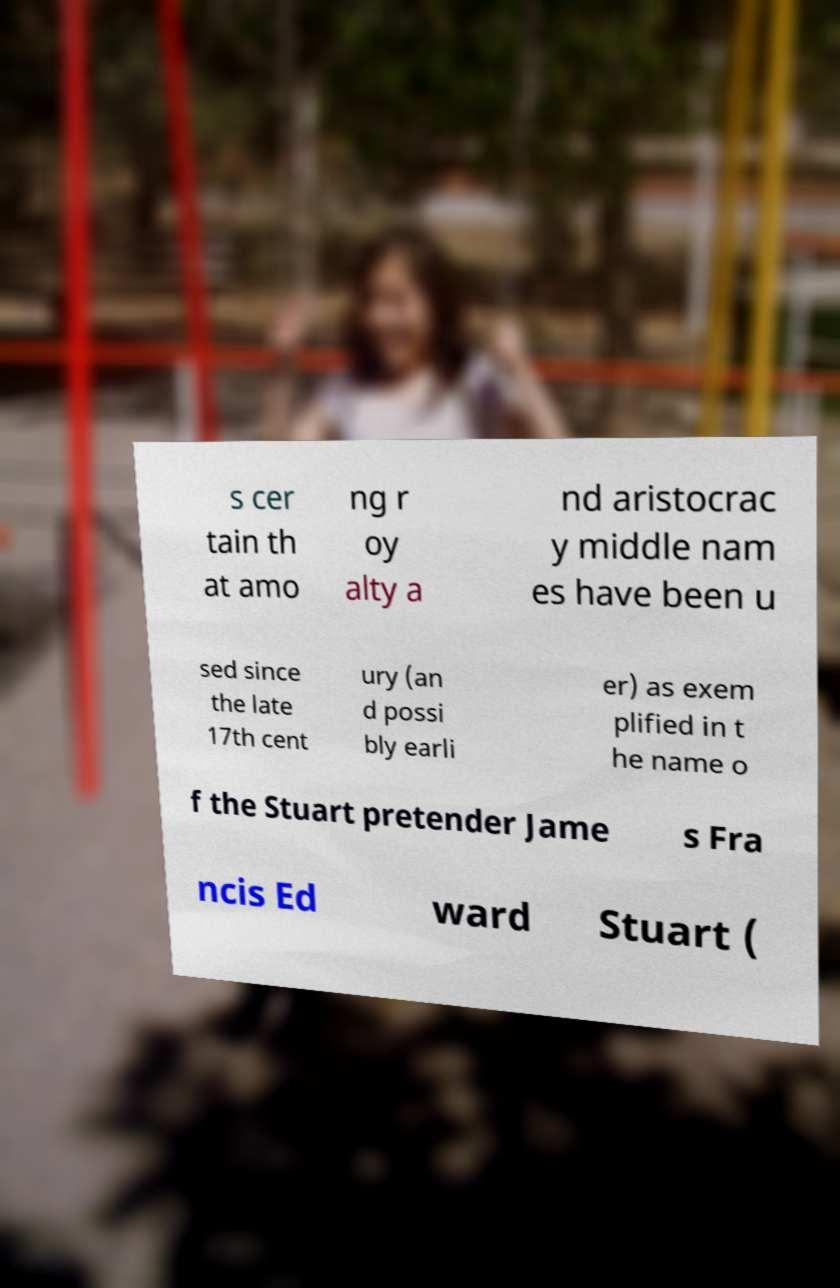There's text embedded in this image that I need extracted. Can you transcribe it verbatim? s cer tain th at amo ng r oy alty a nd aristocrac y middle nam es have been u sed since the late 17th cent ury (an d possi bly earli er) as exem plified in t he name o f the Stuart pretender Jame s Fra ncis Ed ward Stuart ( 